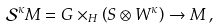<formula> <loc_0><loc_0><loc_500><loc_500>\mathcal { S } ^ { \kappa } M = G \times _ { H } \left ( S \otimes W ^ { \kappa } \right ) \to M \, ,</formula> 